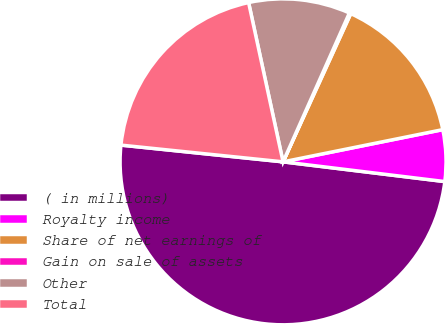<chart> <loc_0><loc_0><loc_500><loc_500><pie_chart><fcel>( in millions)<fcel>Royalty income<fcel>Share of net earnings of<fcel>Gain on sale of assets<fcel>Other<fcel>Total<nl><fcel>49.7%<fcel>5.1%<fcel>15.01%<fcel>0.15%<fcel>10.06%<fcel>19.97%<nl></chart> 